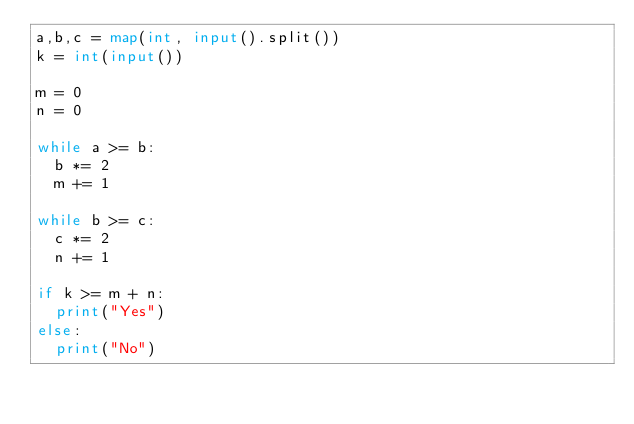<code> <loc_0><loc_0><loc_500><loc_500><_Python_>a,b,c = map(int, input().split())
k = int(input())

m = 0
n = 0

while a >= b:
  b *= 2
  m += 1

while b >= c:
  c *= 2
  n += 1

if k >= m + n:
  print("Yes")
else:
  print("No")</code> 